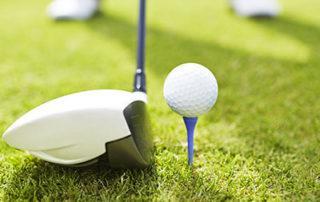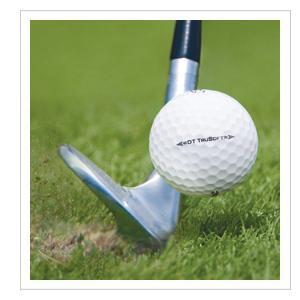The first image is the image on the left, the second image is the image on the right. Evaluate the accuracy of this statement regarding the images: "Golf clubs are near the ball in both images.". Is it true? Answer yes or no. Yes. The first image is the image on the left, the second image is the image on the right. Considering the images on both sides, is "Both golf balls have a golf club next to them." valid? Answer yes or no. Yes. 